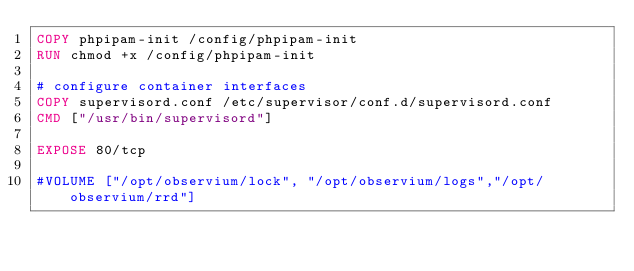<code> <loc_0><loc_0><loc_500><loc_500><_Dockerfile_>COPY phpipam-init /config/phpipam-init
RUN chmod +x /config/phpipam-init

# configure container interfaces
COPY supervisord.conf /etc/supervisor/conf.d/supervisord.conf
CMD ["/usr/bin/supervisord"]

EXPOSE 80/tcp

#VOLUME ["/opt/observium/lock", "/opt/observium/logs","/opt/observium/rrd"]

</code> 